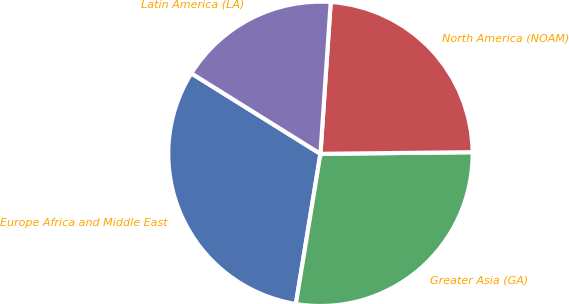Convert chart. <chart><loc_0><loc_0><loc_500><loc_500><pie_chart><fcel>Europe Africa and Middle East<fcel>Greater Asia (GA)<fcel>North America (NOAM)<fcel>Latin America (LA)<nl><fcel>31.29%<fcel>27.75%<fcel>23.75%<fcel>17.2%<nl></chart> 